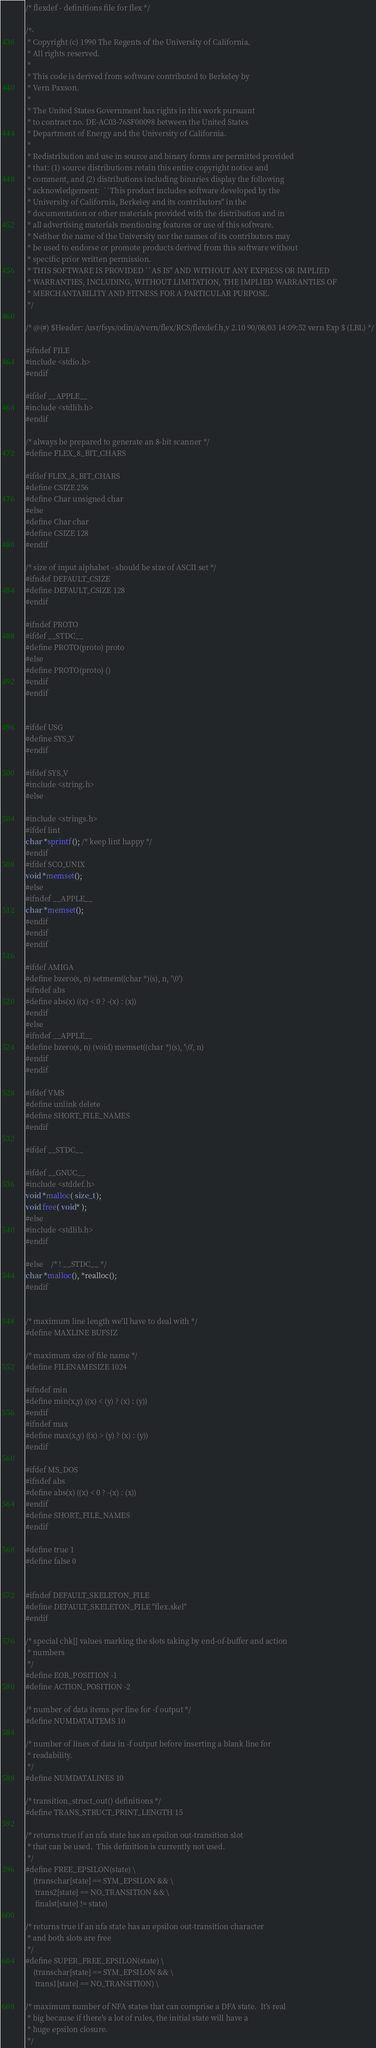<code> <loc_0><loc_0><loc_500><loc_500><_C_>/* flexdef - definitions file for flex */

/*-
 * Copyright (c) 1990 The Regents of the University of California.
 * All rights reserved.
 *
 * This code is derived from software contributed to Berkeley by
 * Vern Paxson.
 * 
 * The United States Government has rights in this work pursuant
 * to contract no. DE-AC03-76SF00098 between the United States
 * Department of Energy and the University of California.
 *
 * Redistribution and use in source and binary forms are permitted provided
 * that: (1) source distributions retain this entire copyright notice and
 * comment, and (2) distributions including binaries display the following
 * acknowledgement:  ``This product includes software developed by the
 * University of California, Berkeley and its contributors'' in the
 * documentation or other materials provided with the distribution and in
 * all advertising materials mentioning features or use of this software.
 * Neither the name of the University nor the names of its contributors may
 * be used to endorse or promote products derived from this software without
 * specific prior written permission.
 * THIS SOFTWARE IS PROVIDED ``AS IS'' AND WITHOUT ANY EXPRESS OR IMPLIED
 * WARRANTIES, INCLUDING, WITHOUT LIMITATION, THE IMPLIED WARRANTIES OF
 * MERCHANTABILITY AND FITNESS FOR A PARTICULAR PURPOSE.
 */

/* @(#) $Header: /usr/fsys/odin/a/vern/flex/RCS/flexdef.h,v 2.10 90/08/03 14:09:52 vern Exp $ (LBL) */

#ifndef FILE
#include <stdio.h>
#endif

#ifdef __APPLE__
#include <stdlib.h>
#endif

/* always be prepared to generate an 8-bit scanner */
#define FLEX_8_BIT_CHARS

#ifdef FLEX_8_BIT_CHARS
#define CSIZE 256
#define Char unsigned char
#else
#define Char char
#define CSIZE 128
#endif

/* size of input alphabet - should be size of ASCII set */
#ifndef DEFAULT_CSIZE
#define DEFAULT_CSIZE 128
#endif

#ifndef PROTO
#ifdef __STDC__
#define PROTO(proto) proto
#else
#define PROTO(proto) ()
#endif
#endif


#ifdef USG
#define SYS_V
#endif

#ifdef SYS_V
#include <string.h>
#else

#include <strings.h>
#ifdef lint
char *sprintf(); /* keep lint happy */
#endif
#ifdef SCO_UNIX
void *memset();
#else
#ifndef __APPLE__
char *memset();
#endif
#endif
#endif

#ifdef AMIGA
#define bzero(s, n) setmem((char *)(s), n, '\0')
#ifndef abs
#define abs(x) ((x) < 0 ? -(x) : (x))
#endif
#else
#ifndef __APPLE__
#define bzero(s, n) (void) memset((char *)(s), '\0', n)
#endif
#endif

#ifdef VMS
#define unlink delete
#define SHORT_FILE_NAMES
#endif

#ifdef __STDC__

#ifdef __GNUC__
#include <stddef.h>
void *malloc( size_t );
void free( void* );
#else
#include <stdlib.h>
#endif

#else	/* ! __STDC__ */
char *malloc(), *realloc();
#endif


/* maximum line length we'll have to deal with */
#define MAXLINE BUFSIZ

/* maximum size of file name */
#define FILENAMESIZE 1024

#ifndef min
#define min(x,y) ((x) < (y) ? (x) : (y))
#endif
#ifndef max
#define max(x,y) ((x) > (y) ? (x) : (y))
#endif

#ifdef MS_DOS
#ifndef abs
#define abs(x) ((x) < 0 ? -(x) : (x))
#endif
#define SHORT_FILE_NAMES
#endif

#define true 1
#define false 0


#ifndef DEFAULT_SKELETON_FILE
#define DEFAULT_SKELETON_FILE "flex.skel"
#endif

/* special chk[] values marking the slots taking by end-of-buffer and action
 * numbers
 */
#define EOB_POSITION -1
#define ACTION_POSITION -2

/* number of data items per line for -f output */
#define NUMDATAITEMS 10

/* number of lines of data in -f output before inserting a blank line for
 * readability.
 */
#define NUMDATALINES 10

/* transition_struct_out() definitions */
#define TRANS_STRUCT_PRINT_LENGTH 15

/* returns true if an nfa state has an epsilon out-transition slot
 * that can be used.  This definition is currently not used.
 */
#define FREE_EPSILON(state) \
	(transchar[state] == SYM_EPSILON && \
	 trans2[state] == NO_TRANSITION && \
	 finalst[state] != state)

/* returns true if an nfa state has an epsilon out-transition character
 * and both slots are free
 */
#define SUPER_FREE_EPSILON(state) \
	(transchar[state] == SYM_EPSILON && \
	 trans1[state] == NO_TRANSITION) \

/* maximum number of NFA states that can comprise a DFA state.  It's real
 * big because if there's a lot of rules, the initial state will have a
 * huge epsilon closure.
 */</code> 